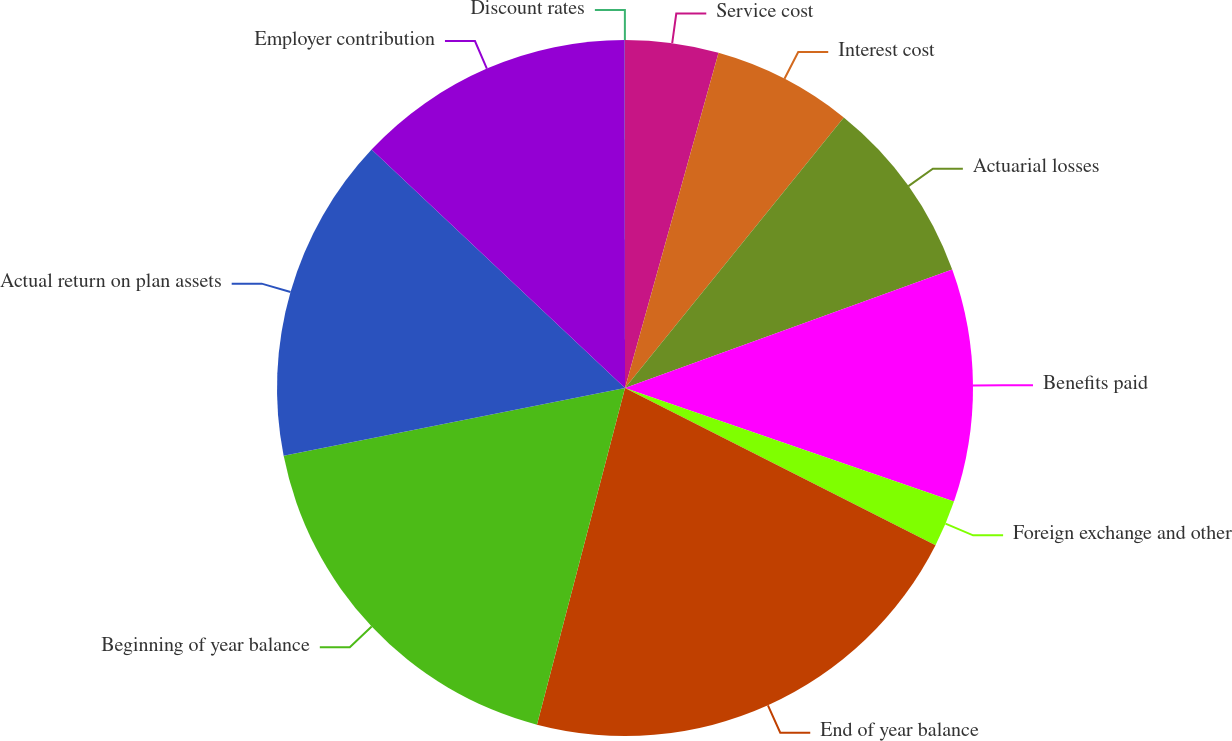Convert chart. <chart><loc_0><loc_0><loc_500><loc_500><pie_chart><fcel>Service cost<fcel>Interest cost<fcel>Actuarial losses<fcel>Benefits paid<fcel>Foreign exchange and other<fcel>End of year balance<fcel>Beginning of year balance<fcel>Actual return on plan assets<fcel>Employer contribution<fcel>Discount rates<nl><fcel>4.33%<fcel>6.49%<fcel>8.65%<fcel>10.81%<fcel>2.17%<fcel>21.61%<fcel>17.81%<fcel>15.13%<fcel>12.97%<fcel>0.01%<nl></chart> 